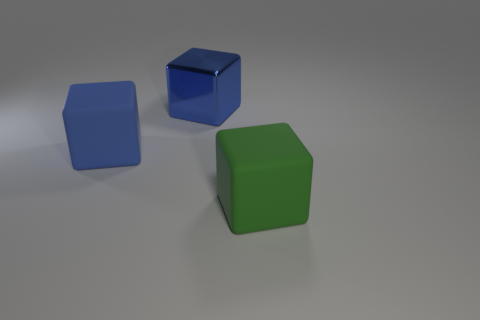Can you describe the color composition and lighting in this scene? The image showcases three cubes with a soft lighting from the top right, casting gentle shadows. The colors present are a vibrant green, a deep blue, and one that appears to be a shade of matte grey or off-white. These colors are set against a neutral grey background, creating a calm and simplistic color composition. 